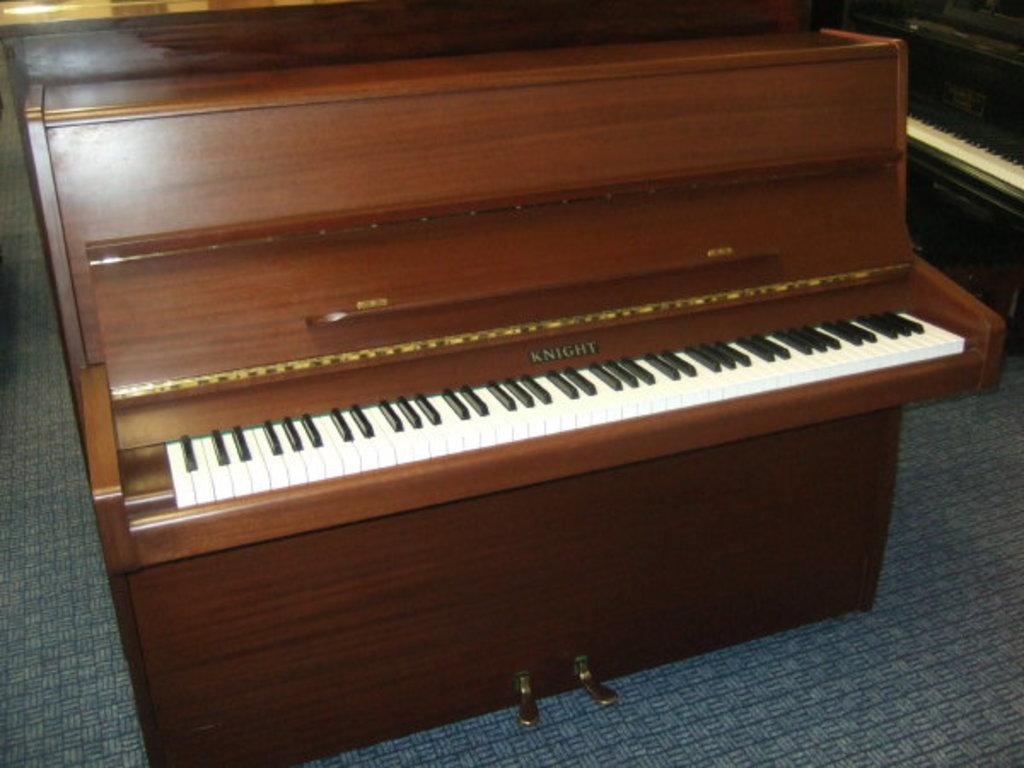Please provide a concise description of this image. In this picture there is a brown color piano placed on the floor. There is also a black color piano placed to the right side of the image. 